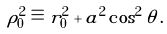Convert formula to latex. <formula><loc_0><loc_0><loc_500><loc_500>\rho _ { 0 } ^ { 2 } \equiv r _ { 0 } ^ { 2 } + a ^ { 2 } \cos ^ { 2 } \theta \, .</formula> 